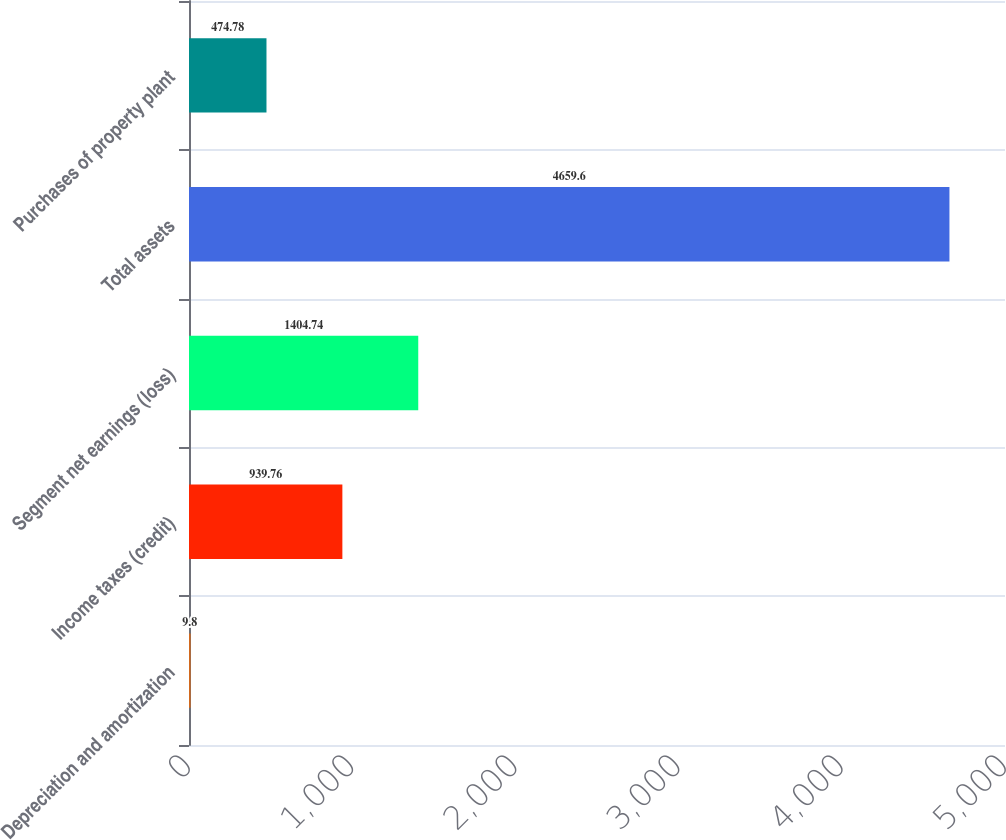Convert chart to OTSL. <chart><loc_0><loc_0><loc_500><loc_500><bar_chart><fcel>Depreciation and amortization<fcel>Income taxes (credit)<fcel>Segment net earnings (loss)<fcel>Total assets<fcel>Purchases of property plant<nl><fcel>9.8<fcel>939.76<fcel>1404.74<fcel>4659.6<fcel>474.78<nl></chart> 